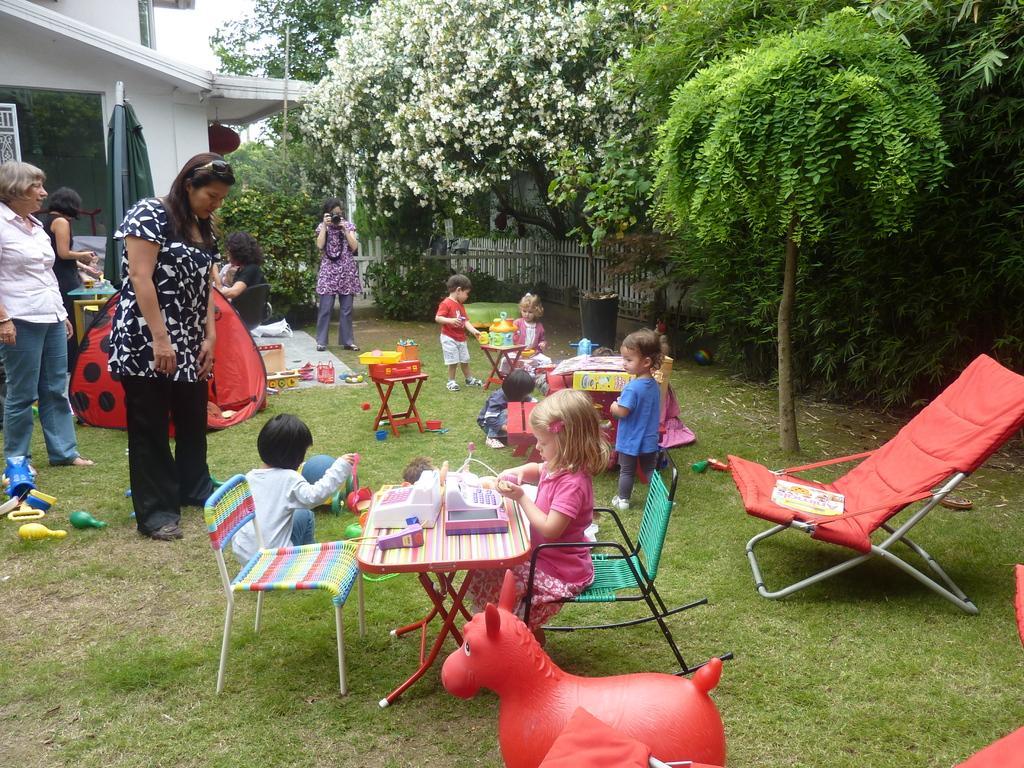Could you give a brief overview of what you see in this image? In this image I can see some people. I can see some objects on the table. On the right side the trees. I can see the white flowers. 